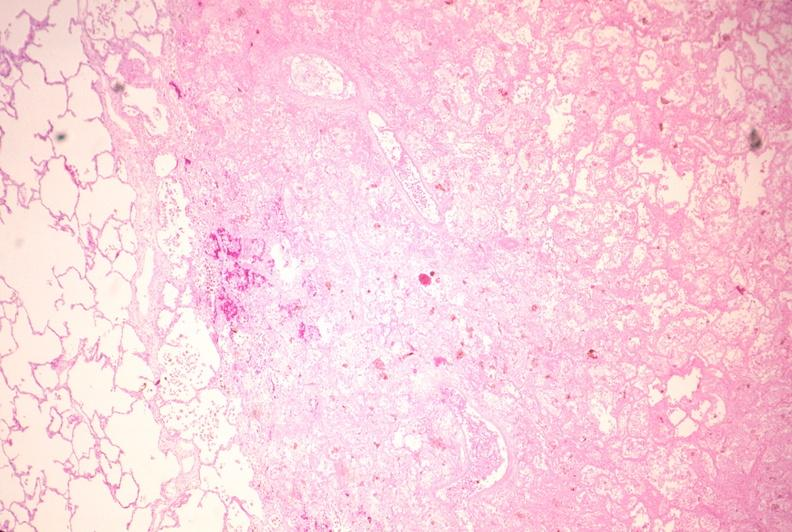does this image show lung, infarct, acute and organized?
Answer the question using a single word or phrase. Yes 